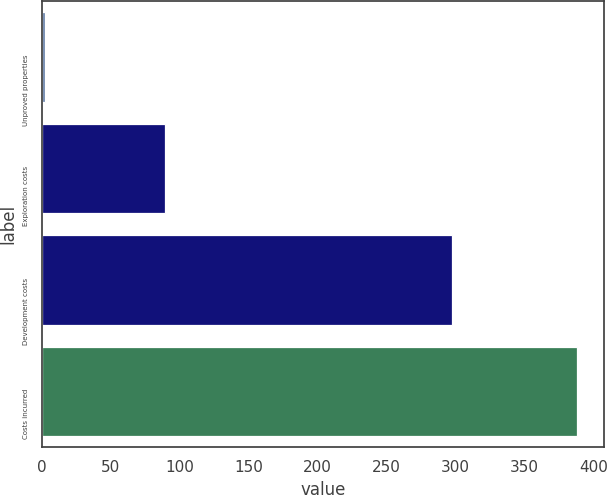Convert chart to OTSL. <chart><loc_0><loc_0><loc_500><loc_500><bar_chart><fcel>Unproved properties<fcel>Exploration costs<fcel>Development costs<fcel>Costs incurred<nl><fcel>2<fcel>89<fcel>297<fcel>388<nl></chart> 